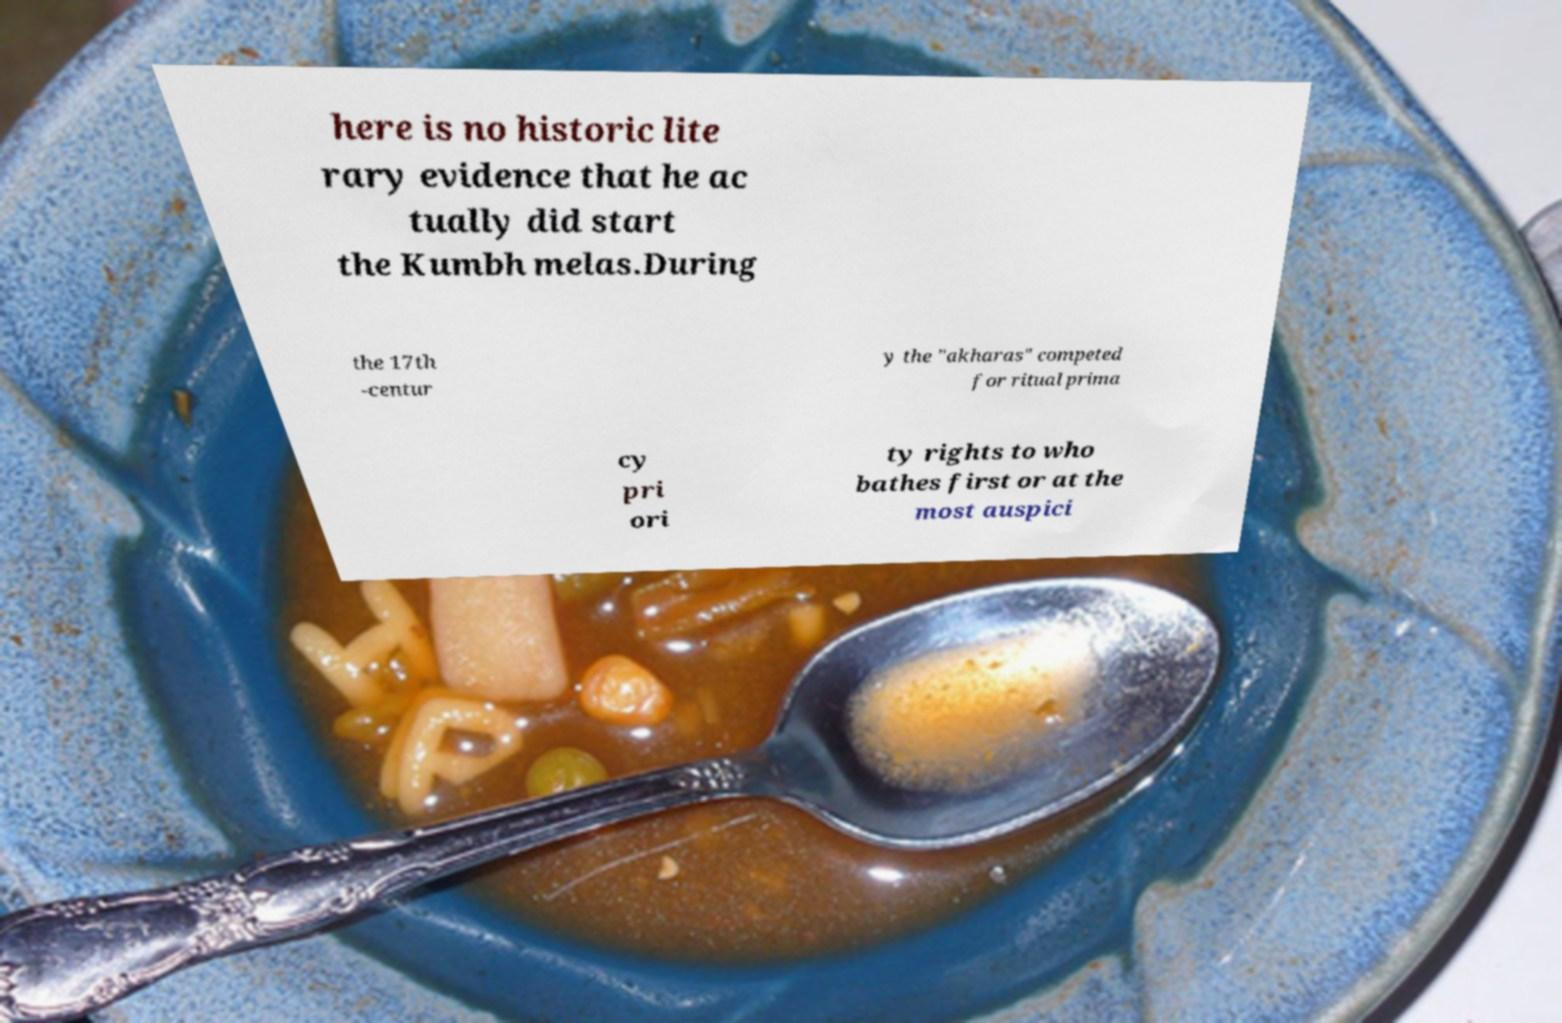There's text embedded in this image that I need extracted. Can you transcribe it verbatim? here is no historic lite rary evidence that he ac tually did start the Kumbh melas.During the 17th -centur y the "akharas" competed for ritual prima cy pri ori ty rights to who bathes first or at the most auspici 